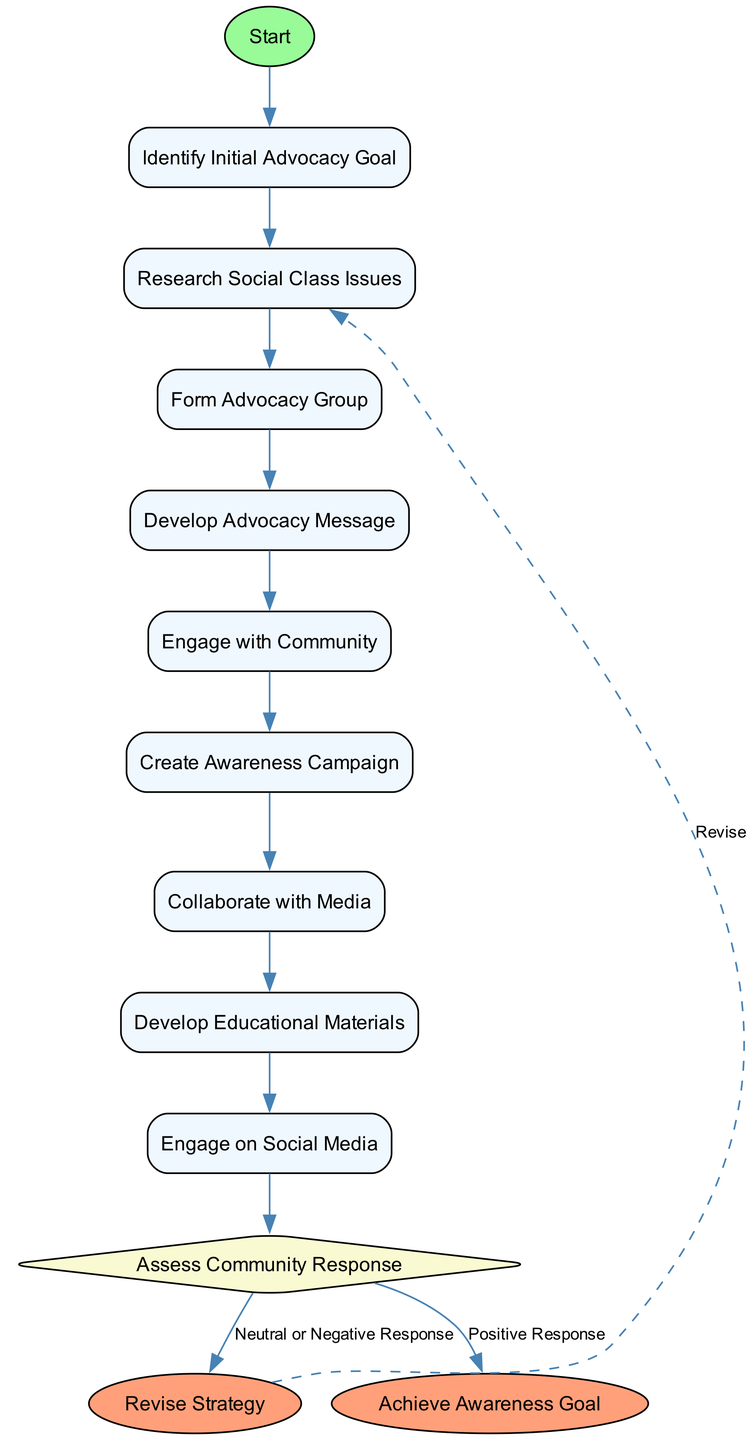What is the initial goal of the advocacy process? The diagram starts with the node labeled "Identify Initial Advocacy Goal," indicating that this is the first step in the process.
Answer: Identify Initial Advocacy Goal How many actions are listed in the diagram? There are a total of 8 actions depicted, which can be counted by identifying each labeled action in the diagram.
Answer: 8 What happens after developing the advocacy message? The next action following "Develop Advocacy Message" is "Engage with Community," as it connects sequentially in the diagram.
Answer: Engage with Community What are the two choices presented in the decision node? The decision node presents two outcomes: "Positive Response" and "Neutral or Negative Response," noted within the diagram's decision area.
Answer: Positive Response, Neutral or Negative Response What is the consequence of a positive response from the community? A positive response leads to achieving the awareness goal, as shown by the connection from the decision node to the end node labeled "Achieve Awareness Goal."
Answer: Achieve Awareness Goal Which action is the last before assessing community response? The last action before the decision is "Create Awareness Campaign," indicated by its position in the flow right before the diamond decision node.
Answer: Create Awareness Campaign How does the process loop back for revising strategies? The "Revise Strategy" node has a dashed edge linking back to the "Research Social Class Issues," indicating a feedback loop for revising efforts based on community feedback.
Answer: Revise Strategy What color represents the start node in the diagram? The start node is colored light green, specifically labeled in the diagram as "#98FB98" in the visual representation.
Answer: Light green 